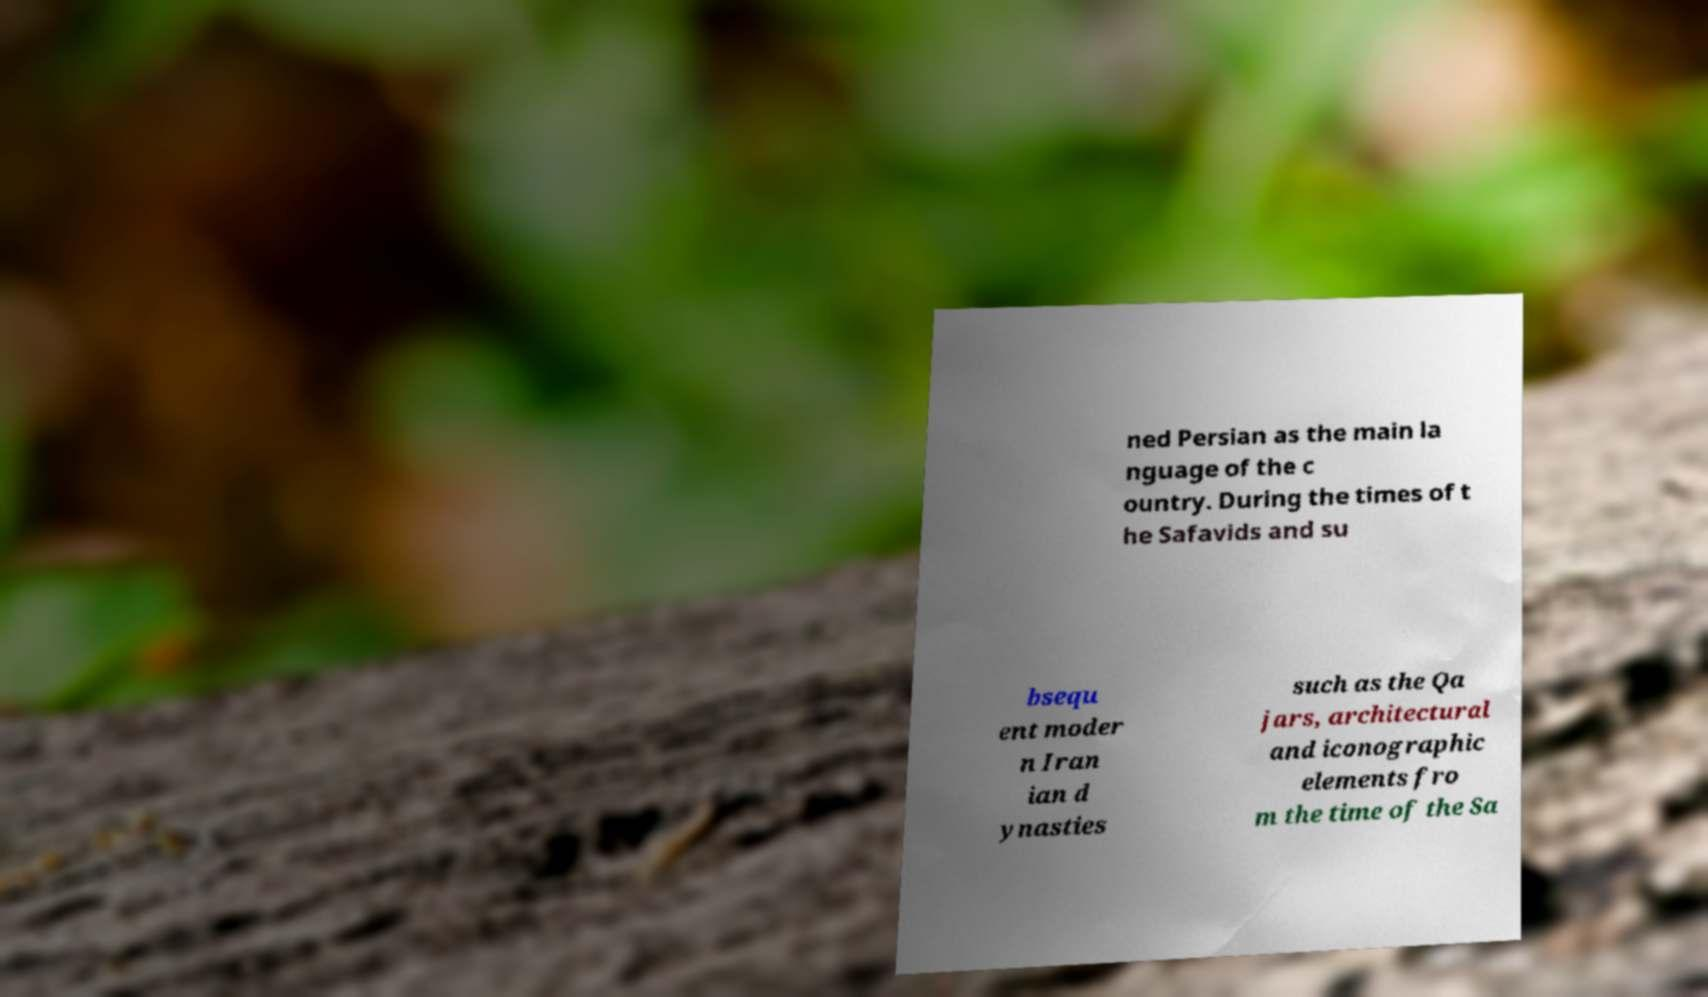There's text embedded in this image that I need extracted. Can you transcribe it verbatim? ned Persian as the main la nguage of the c ountry. During the times of t he Safavids and su bsequ ent moder n Iran ian d ynasties such as the Qa jars, architectural and iconographic elements fro m the time of the Sa 